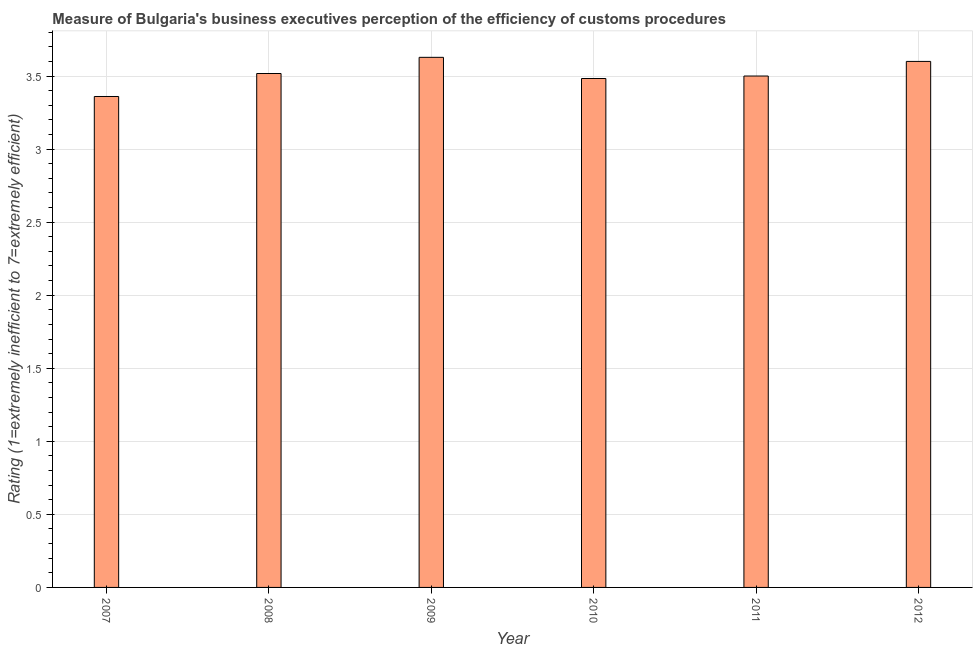Does the graph contain any zero values?
Give a very brief answer. No. Does the graph contain grids?
Your answer should be very brief. Yes. What is the title of the graph?
Offer a terse response. Measure of Bulgaria's business executives perception of the efficiency of customs procedures. What is the label or title of the X-axis?
Give a very brief answer. Year. What is the label or title of the Y-axis?
Provide a short and direct response. Rating (1=extremely inefficient to 7=extremely efficient). What is the rating measuring burden of customs procedure in 2009?
Your answer should be very brief. 3.63. Across all years, what is the maximum rating measuring burden of customs procedure?
Keep it short and to the point. 3.63. Across all years, what is the minimum rating measuring burden of customs procedure?
Keep it short and to the point. 3.36. In which year was the rating measuring burden of customs procedure maximum?
Your answer should be very brief. 2009. What is the sum of the rating measuring burden of customs procedure?
Provide a short and direct response. 21.09. What is the difference between the rating measuring burden of customs procedure in 2008 and 2012?
Offer a terse response. -0.08. What is the average rating measuring burden of customs procedure per year?
Ensure brevity in your answer.  3.52. What is the median rating measuring burden of customs procedure?
Make the answer very short. 3.51. In how many years, is the rating measuring burden of customs procedure greater than 0.9 ?
Your answer should be compact. 6. Is the rating measuring burden of customs procedure in 2007 less than that in 2012?
Offer a very short reply. Yes. Is the difference between the rating measuring burden of customs procedure in 2010 and 2011 greater than the difference between any two years?
Ensure brevity in your answer.  No. What is the difference between the highest and the second highest rating measuring burden of customs procedure?
Your answer should be very brief. 0.03. What is the difference between the highest and the lowest rating measuring burden of customs procedure?
Give a very brief answer. 0.27. How many bars are there?
Offer a terse response. 6. Are all the bars in the graph horizontal?
Ensure brevity in your answer.  No. How many years are there in the graph?
Offer a terse response. 6. What is the difference between two consecutive major ticks on the Y-axis?
Provide a short and direct response. 0.5. Are the values on the major ticks of Y-axis written in scientific E-notation?
Ensure brevity in your answer.  No. What is the Rating (1=extremely inefficient to 7=extremely efficient) of 2007?
Ensure brevity in your answer.  3.36. What is the Rating (1=extremely inefficient to 7=extremely efficient) of 2008?
Your answer should be very brief. 3.52. What is the Rating (1=extremely inefficient to 7=extremely efficient) of 2009?
Provide a short and direct response. 3.63. What is the Rating (1=extremely inefficient to 7=extremely efficient) of 2010?
Ensure brevity in your answer.  3.48. What is the difference between the Rating (1=extremely inefficient to 7=extremely efficient) in 2007 and 2008?
Make the answer very short. -0.16. What is the difference between the Rating (1=extremely inefficient to 7=extremely efficient) in 2007 and 2009?
Your response must be concise. -0.27. What is the difference between the Rating (1=extremely inefficient to 7=extremely efficient) in 2007 and 2010?
Your response must be concise. -0.12. What is the difference between the Rating (1=extremely inefficient to 7=extremely efficient) in 2007 and 2011?
Provide a short and direct response. -0.14. What is the difference between the Rating (1=extremely inefficient to 7=extremely efficient) in 2007 and 2012?
Provide a short and direct response. -0.24. What is the difference between the Rating (1=extremely inefficient to 7=extremely efficient) in 2008 and 2009?
Offer a very short reply. -0.11. What is the difference between the Rating (1=extremely inefficient to 7=extremely efficient) in 2008 and 2010?
Offer a very short reply. 0.03. What is the difference between the Rating (1=extremely inefficient to 7=extremely efficient) in 2008 and 2011?
Your answer should be compact. 0.02. What is the difference between the Rating (1=extremely inefficient to 7=extremely efficient) in 2008 and 2012?
Your response must be concise. -0.08. What is the difference between the Rating (1=extremely inefficient to 7=extremely efficient) in 2009 and 2010?
Your response must be concise. 0.14. What is the difference between the Rating (1=extremely inefficient to 7=extremely efficient) in 2009 and 2011?
Your answer should be compact. 0.13. What is the difference between the Rating (1=extremely inefficient to 7=extremely efficient) in 2009 and 2012?
Your response must be concise. 0.03. What is the difference between the Rating (1=extremely inefficient to 7=extremely efficient) in 2010 and 2011?
Offer a very short reply. -0.02. What is the difference between the Rating (1=extremely inefficient to 7=extremely efficient) in 2010 and 2012?
Your answer should be very brief. -0.12. What is the difference between the Rating (1=extremely inefficient to 7=extremely efficient) in 2011 and 2012?
Provide a short and direct response. -0.1. What is the ratio of the Rating (1=extremely inefficient to 7=extremely efficient) in 2007 to that in 2008?
Provide a short and direct response. 0.95. What is the ratio of the Rating (1=extremely inefficient to 7=extremely efficient) in 2007 to that in 2009?
Your answer should be compact. 0.93. What is the ratio of the Rating (1=extremely inefficient to 7=extremely efficient) in 2007 to that in 2010?
Your answer should be very brief. 0.96. What is the ratio of the Rating (1=extremely inefficient to 7=extremely efficient) in 2007 to that in 2011?
Make the answer very short. 0.96. What is the ratio of the Rating (1=extremely inefficient to 7=extremely efficient) in 2007 to that in 2012?
Ensure brevity in your answer.  0.93. What is the ratio of the Rating (1=extremely inefficient to 7=extremely efficient) in 2008 to that in 2010?
Your answer should be compact. 1.01. What is the ratio of the Rating (1=extremely inefficient to 7=extremely efficient) in 2009 to that in 2010?
Offer a terse response. 1.04. What is the ratio of the Rating (1=extremely inefficient to 7=extremely efficient) in 2009 to that in 2011?
Make the answer very short. 1.04. What is the ratio of the Rating (1=extremely inefficient to 7=extremely efficient) in 2009 to that in 2012?
Offer a very short reply. 1.01. What is the ratio of the Rating (1=extremely inefficient to 7=extremely efficient) in 2010 to that in 2011?
Offer a very short reply. 0.99. What is the ratio of the Rating (1=extremely inefficient to 7=extremely efficient) in 2010 to that in 2012?
Give a very brief answer. 0.97. What is the ratio of the Rating (1=extremely inefficient to 7=extremely efficient) in 2011 to that in 2012?
Offer a very short reply. 0.97. 